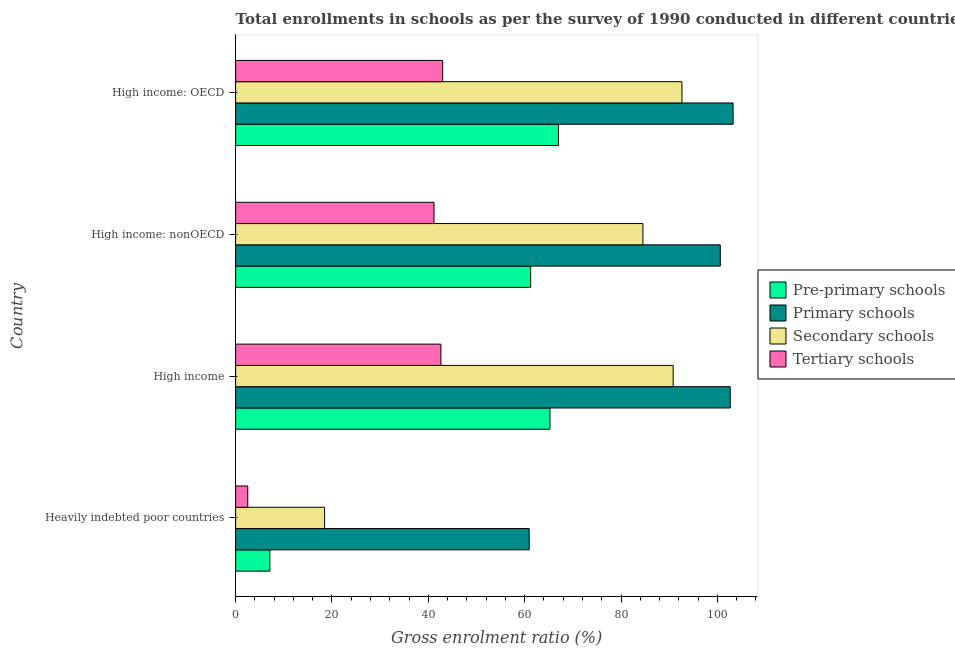How many different coloured bars are there?
Make the answer very short. 4. How many groups of bars are there?
Ensure brevity in your answer.  4. Are the number of bars per tick equal to the number of legend labels?
Offer a terse response. Yes. Are the number of bars on each tick of the Y-axis equal?
Your answer should be compact. Yes. What is the label of the 2nd group of bars from the top?
Ensure brevity in your answer.  High income: nonOECD. In how many cases, is the number of bars for a given country not equal to the number of legend labels?
Provide a succinct answer. 0. What is the gross enrolment ratio in pre-primary schools in High income: nonOECD?
Your answer should be very brief. 61.25. Across all countries, what is the maximum gross enrolment ratio in pre-primary schools?
Ensure brevity in your answer.  67.03. Across all countries, what is the minimum gross enrolment ratio in secondary schools?
Ensure brevity in your answer.  18.47. In which country was the gross enrolment ratio in secondary schools maximum?
Your response must be concise. High income: OECD. In which country was the gross enrolment ratio in primary schools minimum?
Offer a very short reply. Heavily indebted poor countries. What is the total gross enrolment ratio in pre-primary schools in the graph?
Your answer should be very brief. 200.64. What is the difference between the gross enrolment ratio in primary schools in High income: OECD and that in High income: nonOECD?
Give a very brief answer. 2.66. What is the difference between the gross enrolment ratio in primary schools in Heavily indebted poor countries and the gross enrolment ratio in pre-primary schools in High income: nonOECD?
Offer a terse response. -0.3. What is the average gross enrolment ratio in secondary schools per country?
Keep it short and to the point. 71.63. What is the difference between the gross enrolment ratio in pre-primary schools and gross enrolment ratio in secondary schools in High income?
Keep it short and to the point. -25.58. Is the gross enrolment ratio in tertiary schools in High income less than that in High income: nonOECD?
Provide a short and direct response. No. What is the difference between the highest and the second highest gross enrolment ratio in secondary schools?
Make the answer very short. 1.82. What is the difference between the highest and the lowest gross enrolment ratio in secondary schools?
Provide a short and direct response. 74.19. What does the 4th bar from the top in High income: OECD represents?
Your answer should be compact. Pre-primary schools. What does the 4th bar from the bottom in High income: OECD represents?
Your answer should be very brief. Tertiary schools. Is it the case that in every country, the sum of the gross enrolment ratio in pre-primary schools and gross enrolment ratio in primary schools is greater than the gross enrolment ratio in secondary schools?
Provide a short and direct response. Yes. Are all the bars in the graph horizontal?
Ensure brevity in your answer.  Yes. What is the difference between two consecutive major ticks on the X-axis?
Ensure brevity in your answer.  20. Does the graph contain any zero values?
Make the answer very short. No. How many legend labels are there?
Offer a terse response. 4. What is the title of the graph?
Offer a very short reply. Total enrollments in schools as per the survey of 1990 conducted in different countries. What is the label or title of the X-axis?
Ensure brevity in your answer.  Gross enrolment ratio (%). What is the label or title of the Y-axis?
Your answer should be very brief. Country. What is the Gross enrolment ratio (%) of Pre-primary schools in Heavily indebted poor countries?
Keep it short and to the point. 7.11. What is the Gross enrolment ratio (%) in Primary schools in Heavily indebted poor countries?
Your response must be concise. 60.95. What is the Gross enrolment ratio (%) of Secondary schools in Heavily indebted poor countries?
Your answer should be very brief. 18.47. What is the Gross enrolment ratio (%) of Tertiary schools in Heavily indebted poor countries?
Your response must be concise. 2.52. What is the Gross enrolment ratio (%) of Pre-primary schools in High income?
Ensure brevity in your answer.  65.26. What is the Gross enrolment ratio (%) of Primary schools in High income?
Your answer should be compact. 102.68. What is the Gross enrolment ratio (%) in Secondary schools in High income?
Provide a short and direct response. 90.83. What is the Gross enrolment ratio (%) of Tertiary schools in High income?
Offer a very short reply. 42.61. What is the Gross enrolment ratio (%) of Pre-primary schools in High income: nonOECD?
Provide a short and direct response. 61.25. What is the Gross enrolment ratio (%) in Primary schools in High income: nonOECD?
Your response must be concise. 100.61. What is the Gross enrolment ratio (%) in Secondary schools in High income: nonOECD?
Ensure brevity in your answer.  84.55. What is the Gross enrolment ratio (%) in Tertiary schools in High income: nonOECD?
Offer a very short reply. 41.18. What is the Gross enrolment ratio (%) in Pre-primary schools in High income: OECD?
Make the answer very short. 67.03. What is the Gross enrolment ratio (%) in Primary schools in High income: OECD?
Give a very brief answer. 103.27. What is the Gross enrolment ratio (%) in Secondary schools in High income: OECD?
Keep it short and to the point. 92.65. What is the Gross enrolment ratio (%) in Tertiary schools in High income: OECD?
Offer a very short reply. 42.98. Across all countries, what is the maximum Gross enrolment ratio (%) in Pre-primary schools?
Provide a succinct answer. 67.03. Across all countries, what is the maximum Gross enrolment ratio (%) in Primary schools?
Give a very brief answer. 103.27. Across all countries, what is the maximum Gross enrolment ratio (%) in Secondary schools?
Offer a terse response. 92.65. Across all countries, what is the maximum Gross enrolment ratio (%) in Tertiary schools?
Give a very brief answer. 42.98. Across all countries, what is the minimum Gross enrolment ratio (%) in Pre-primary schools?
Your answer should be very brief. 7.11. Across all countries, what is the minimum Gross enrolment ratio (%) in Primary schools?
Your answer should be very brief. 60.95. Across all countries, what is the minimum Gross enrolment ratio (%) of Secondary schools?
Provide a succinct answer. 18.47. Across all countries, what is the minimum Gross enrolment ratio (%) in Tertiary schools?
Offer a very short reply. 2.52. What is the total Gross enrolment ratio (%) in Pre-primary schools in the graph?
Your answer should be very brief. 200.64. What is the total Gross enrolment ratio (%) of Primary schools in the graph?
Your response must be concise. 367.5. What is the total Gross enrolment ratio (%) in Secondary schools in the graph?
Provide a short and direct response. 286.5. What is the total Gross enrolment ratio (%) in Tertiary schools in the graph?
Make the answer very short. 129.29. What is the difference between the Gross enrolment ratio (%) of Pre-primary schools in Heavily indebted poor countries and that in High income?
Provide a succinct answer. -58.15. What is the difference between the Gross enrolment ratio (%) in Primary schools in Heavily indebted poor countries and that in High income?
Provide a short and direct response. -41.73. What is the difference between the Gross enrolment ratio (%) of Secondary schools in Heavily indebted poor countries and that in High income?
Your answer should be compact. -72.36. What is the difference between the Gross enrolment ratio (%) of Tertiary schools in Heavily indebted poor countries and that in High income?
Give a very brief answer. -40.09. What is the difference between the Gross enrolment ratio (%) in Pre-primary schools in Heavily indebted poor countries and that in High income: nonOECD?
Make the answer very short. -54.14. What is the difference between the Gross enrolment ratio (%) of Primary schools in Heavily indebted poor countries and that in High income: nonOECD?
Your answer should be very brief. -39.66. What is the difference between the Gross enrolment ratio (%) of Secondary schools in Heavily indebted poor countries and that in High income: nonOECD?
Provide a succinct answer. -66.08. What is the difference between the Gross enrolment ratio (%) in Tertiary schools in Heavily indebted poor countries and that in High income: nonOECD?
Your answer should be compact. -38.66. What is the difference between the Gross enrolment ratio (%) in Pre-primary schools in Heavily indebted poor countries and that in High income: OECD?
Provide a succinct answer. -59.92. What is the difference between the Gross enrolment ratio (%) in Primary schools in Heavily indebted poor countries and that in High income: OECD?
Your response must be concise. -42.33. What is the difference between the Gross enrolment ratio (%) of Secondary schools in Heavily indebted poor countries and that in High income: OECD?
Make the answer very short. -74.19. What is the difference between the Gross enrolment ratio (%) in Tertiary schools in Heavily indebted poor countries and that in High income: OECD?
Offer a very short reply. -40.46. What is the difference between the Gross enrolment ratio (%) in Pre-primary schools in High income and that in High income: nonOECD?
Provide a succinct answer. 4.01. What is the difference between the Gross enrolment ratio (%) in Primary schools in High income and that in High income: nonOECD?
Provide a short and direct response. 2.07. What is the difference between the Gross enrolment ratio (%) in Secondary schools in High income and that in High income: nonOECD?
Give a very brief answer. 6.28. What is the difference between the Gross enrolment ratio (%) of Tertiary schools in High income and that in High income: nonOECD?
Ensure brevity in your answer.  1.43. What is the difference between the Gross enrolment ratio (%) in Pre-primary schools in High income and that in High income: OECD?
Your response must be concise. -1.77. What is the difference between the Gross enrolment ratio (%) of Primary schools in High income and that in High income: OECD?
Offer a very short reply. -0.59. What is the difference between the Gross enrolment ratio (%) of Secondary schools in High income and that in High income: OECD?
Offer a terse response. -1.82. What is the difference between the Gross enrolment ratio (%) of Tertiary schools in High income and that in High income: OECD?
Your answer should be very brief. -0.37. What is the difference between the Gross enrolment ratio (%) in Pre-primary schools in High income: nonOECD and that in High income: OECD?
Provide a short and direct response. -5.78. What is the difference between the Gross enrolment ratio (%) in Primary schools in High income: nonOECD and that in High income: OECD?
Provide a succinct answer. -2.66. What is the difference between the Gross enrolment ratio (%) of Secondary schools in High income: nonOECD and that in High income: OECD?
Keep it short and to the point. -8.11. What is the difference between the Gross enrolment ratio (%) in Tertiary schools in High income: nonOECD and that in High income: OECD?
Offer a very short reply. -1.79. What is the difference between the Gross enrolment ratio (%) of Pre-primary schools in Heavily indebted poor countries and the Gross enrolment ratio (%) of Primary schools in High income?
Offer a very short reply. -95.57. What is the difference between the Gross enrolment ratio (%) of Pre-primary schools in Heavily indebted poor countries and the Gross enrolment ratio (%) of Secondary schools in High income?
Your answer should be very brief. -83.72. What is the difference between the Gross enrolment ratio (%) of Pre-primary schools in Heavily indebted poor countries and the Gross enrolment ratio (%) of Tertiary schools in High income?
Give a very brief answer. -35.5. What is the difference between the Gross enrolment ratio (%) in Primary schools in Heavily indebted poor countries and the Gross enrolment ratio (%) in Secondary schools in High income?
Your response must be concise. -29.89. What is the difference between the Gross enrolment ratio (%) in Primary schools in Heavily indebted poor countries and the Gross enrolment ratio (%) in Tertiary schools in High income?
Your answer should be compact. 18.33. What is the difference between the Gross enrolment ratio (%) in Secondary schools in Heavily indebted poor countries and the Gross enrolment ratio (%) in Tertiary schools in High income?
Offer a terse response. -24.14. What is the difference between the Gross enrolment ratio (%) of Pre-primary schools in Heavily indebted poor countries and the Gross enrolment ratio (%) of Primary schools in High income: nonOECD?
Give a very brief answer. -93.5. What is the difference between the Gross enrolment ratio (%) in Pre-primary schools in Heavily indebted poor countries and the Gross enrolment ratio (%) in Secondary schools in High income: nonOECD?
Offer a very short reply. -77.44. What is the difference between the Gross enrolment ratio (%) in Pre-primary schools in Heavily indebted poor countries and the Gross enrolment ratio (%) in Tertiary schools in High income: nonOECD?
Provide a short and direct response. -34.07. What is the difference between the Gross enrolment ratio (%) of Primary schools in Heavily indebted poor countries and the Gross enrolment ratio (%) of Secondary schools in High income: nonOECD?
Offer a terse response. -23.6. What is the difference between the Gross enrolment ratio (%) of Primary schools in Heavily indebted poor countries and the Gross enrolment ratio (%) of Tertiary schools in High income: nonOECD?
Offer a terse response. 19.76. What is the difference between the Gross enrolment ratio (%) in Secondary schools in Heavily indebted poor countries and the Gross enrolment ratio (%) in Tertiary schools in High income: nonOECD?
Your answer should be compact. -22.71. What is the difference between the Gross enrolment ratio (%) of Pre-primary schools in Heavily indebted poor countries and the Gross enrolment ratio (%) of Primary schools in High income: OECD?
Offer a terse response. -96.16. What is the difference between the Gross enrolment ratio (%) of Pre-primary schools in Heavily indebted poor countries and the Gross enrolment ratio (%) of Secondary schools in High income: OECD?
Offer a terse response. -85.54. What is the difference between the Gross enrolment ratio (%) of Pre-primary schools in Heavily indebted poor countries and the Gross enrolment ratio (%) of Tertiary schools in High income: OECD?
Keep it short and to the point. -35.87. What is the difference between the Gross enrolment ratio (%) of Primary schools in Heavily indebted poor countries and the Gross enrolment ratio (%) of Secondary schools in High income: OECD?
Your response must be concise. -31.71. What is the difference between the Gross enrolment ratio (%) in Primary schools in Heavily indebted poor countries and the Gross enrolment ratio (%) in Tertiary schools in High income: OECD?
Ensure brevity in your answer.  17.97. What is the difference between the Gross enrolment ratio (%) in Secondary schools in Heavily indebted poor countries and the Gross enrolment ratio (%) in Tertiary schools in High income: OECD?
Make the answer very short. -24.51. What is the difference between the Gross enrolment ratio (%) in Pre-primary schools in High income and the Gross enrolment ratio (%) in Primary schools in High income: nonOECD?
Ensure brevity in your answer.  -35.35. What is the difference between the Gross enrolment ratio (%) of Pre-primary schools in High income and the Gross enrolment ratio (%) of Secondary schools in High income: nonOECD?
Offer a terse response. -19.29. What is the difference between the Gross enrolment ratio (%) in Pre-primary schools in High income and the Gross enrolment ratio (%) in Tertiary schools in High income: nonOECD?
Ensure brevity in your answer.  24.07. What is the difference between the Gross enrolment ratio (%) in Primary schools in High income and the Gross enrolment ratio (%) in Secondary schools in High income: nonOECD?
Keep it short and to the point. 18.13. What is the difference between the Gross enrolment ratio (%) in Primary schools in High income and the Gross enrolment ratio (%) in Tertiary schools in High income: nonOECD?
Your answer should be very brief. 61.49. What is the difference between the Gross enrolment ratio (%) of Secondary schools in High income and the Gross enrolment ratio (%) of Tertiary schools in High income: nonOECD?
Provide a succinct answer. 49.65. What is the difference between the Gross enrolment ratio (%) in Pre-primary schools in High income and the Gross enrolment ratio (%) in Primary schools in High income: OECD?
Ensure brevity in your answer.  -38.02. What is the difference between the Gross enrolment ratio (%) of Pre-primary schools in High income and the Gross enrolment ratio (%) of Secondary schools in High income: OECD?
Give a very brief answer. -27.4. What is the difference between the Gross enrolment ratio (%) in Pre-primary schools in High income and the Gross enrolment ratio (%) in Tertiary schools in High income: OECD?
Offer a very short reply. 22.28. What is the difference between the Gross enrolment ratio (%) in Primary schools in High income and the Gross enrolment ratio (%) in Secondary schools in High income: OECD?
Provide a succinct answer. 10.02. What is the difference between the Gross enrolment ratio (%) of Primary schools in High income and the Gross enrolment ratio (%) of Tertiary schools in High income: OECD?
Make the answer very short. 59.7. What is the difference between the Gross enrolment ratio (%) of Secondary schools in High income and the Gross enrolment ratio (%) of Tertiary schools in High income: OECD?
Your answer should be very brief. 47.85. What is the difference between the Gross enrolment ratio (%) in Pre-primary schools in High income: nonOECD and the Gross enrolment ratio (%) in Primary schools in High income: OECD?
Your answer should be compact. -42.03. What is the difference between the Gross enrolment ratio (%) of Pre-primary schools in High income: nonOECD and the Gross enrolment ratio (%) of Secondary schools in High income: OECD?
Give a very brief answer. -31.41. What is the difference between the Gross enrolment ratio (%) of Pre-primary schools in High income: nonOECD and the Gross enrolment ratio (%) of Tertiary schools in High income: OECD?
Offer a very short reply. 18.27. What is the difference between the Gross enrolment ratio (%) of Primary schools in High income: nonOECD and the Gross enrolment ratio (%) of Secondary schools in High income: OECD?
Make the answer very short. 7.96. What is the difference between the Gross enrolment ratio (%) of Primary schools in High income: nonOECD and the Gross enrolment ratio (%) of Tertiary schools in High income: OECD?
Your response must be concise. 57.63. What is the difference between the Gross enrolment ratio (%) in Secondary schools in High income: nonOECD and the Gross enrolment ratio (%) in Tertiary schools in High income: OECD?
Your answer should be very brief. 41.57. What is the average Gross enrolment ratio (%) in Pre-primary schools per country?
Provide a short and direct response. 50.16. What is the average Gross enrolment ratio (%) of Primary schools per country?
Your response must be concise. 91.88. What is the average Gross enrolment ratio (%) of Secondary schools per country?
Provide a succinct answer. 71.63. What is the average Gross enrolment ratio (%) in Tertiary schools per country?
Make the answer very short. 32.32. What is the difference between the Gross enrolment ratio (%) in Pre-primary schools and Gross enrolment ratio (%) in Primary schools in Heavily indebted poor countries?
Keep it short and to the point. -53.84. What is the difference between the Gross enrolment ratio (%) in Pre-primary schools and Gross enrolment ratio (%) in Secondary schools in Heavily indebted poor countries?
Provide a short and direct response. -11.36. What is the difference between the Gross enrolment ratio (%) in Pre-primary schools and Gross enrolment ratio (%) in Tertiary schools in Heavily indebted poor countries?
Give a very brief answer. 4.59. What is the difference between the Gross enrolment ratio (%) of Primary schools and Gross enrolment ratio (%) of Secondary schools in Heavily indebted poor countries?
Your response must be concise. 42.48. What is the difference between the Gross enrolment ratio (%) of Primary schools and Gross enrolment ratio (%) of Tertiary schools in Heavily indebted poor countries?
Offer a terse response. 58.42. What is the difference between the Gross enrolment ratio (%) of Secondary schools and Gross enrolment ratio (%) of Tertiary schools in Heavily indebted poor countries?
Give a very brief answer. 15.95. What is the difference between the Gross enrolment ratio (%) of Pre-primary schools and Gross enrolment ratio (%) of Primary schools in High income?
Provide a short and direct response. -37.42. What is the difference between the Gross enrolment ratio (%) of Pre-primary schools and Gross enrolment ratio (%) of Secondary schools in High income?
Give a very brief answer. -25.58. What is the difference between the Gross enrolment ratio (%) in Pre-primary schools and Gross enrolment ratio (%) in Tertiary schools in High income?
Offer a terse response. 22.64. What is the difference between the Gross enrolment ratio (%) of Primary schools and Gross enrolment ratio (%) of Secondary schools in High income?
Provide a succinct answer. 11.85. What is the difference between the Gross enrolment ratio (%) of Primary schools and Gross enrolment ratio (%) of Tertiary schools in High income?
Provide a short and direct response. 60.06. What is the difference between the Gross enrolment ratio (%) in Secondary schools and Gross enrolment ratio (%) in Tertiary schools in High income?
Offer a very short reply. 48.22. What is the difference between the Gross enrolment ratio (%) of Pre-primary schools and Gross enrolment ratio (%) of Primary schools in High income: nonOECD?
Your answer should be compact. -39.36. What is the difference between the Gross enrolment ratio (%) of Pre-primary schools and Gross enrolment ratio (%) of Secondary schools in High income: nonOECD?
Give a very brief answer. -23.3. What is the difference between the Gross enrolment ratio (%) in Pre-primary schools and Gross enrolment ratio (%) in Tertiary schools in High income: nonOECD?
Your response must be concise. 20.06. What is the difference between the Gross enrolment ratio (%) in Primary schools and Gross enrolment ratio (%) in Secondary schools in High income: nonOECD?
Your response must be concise. 16.06. What is the difference between the Gross enrolment ratio (%) in Primary schools and Gross enrolment ratio (%) in Tertiary schools in High income: nonOECD?
Provide a short and direct response. 59.43. What is the difference between the Gross enrolment ratio (%) of Secondary schools and Gross enrolment ratio (%) of Tertiary schools in High income: nonOECD?
Make the answer very short. 43.36. What is the difference between the Gross enrolment ratio (%) of Pre-primary schools and Gross enrolment ratio (%) of Primary schools in High income: OECD?
Your response must be concise. -36.24. What is the difference between the Gross enrolment ratio (%) of Pre-primary schools and Gross enrolment ratio (%) of Secondary schools in High income: OECD?
Offer a very short reply. -25.63. What is the difference between the Gross enrolment ratio (%) in Pre-primary schools and Gross enrolment ratio (%) in Tertiary schools in High income: OECD?
Your answer should be very brief. 24.05. What is the difference between the Gross enrolment ratio (%) of Primary schools and Gross enrolment ratio (%) of Secondary schools in High income: OECD?
Give a very brief answer. 10.62. What is the difference between the Gross enrolment ratio (%) of Primary schools and Gross enrolment ratio (%) of Tertiary schools in High income: OECD?
Give a very brief answer. 60.29. What is the difference between the Gross enrolment ratio (%) of Secondary schools and Gross enrolment ratio (%) of Tertiary schools in High income: OECD?
Your response must be concise. 49.68. What is the ratio of the Gross enrolment ratio (%) in Pre-primary schools in Heavily indebted poor countries to that in High income?
Your answer should be compact. 0.11. What is the ratio of the Gross enrolment ratio (%) of Primary schools in Heavily indebted poor countries to that in High income?
Provide a short and direct response. 0.59. What is the ratio of the Gross enrolment ratio (%) in Secondary schools in Heavily indebted poor countries to that in High income?
Offer a terse response. 0.2. What is the ratio of the Gross enrolment ratio (%) of Tertiary schools in Heavily indebted poor countries to that in High income?
Your answer should be very brief. 0.06. What is the ratio of the Gross enrolment ratio (%) of Pre-primary schools in Heavily indebted poor countries to that in High income: nonOECD?
Make the answer very short. 0.12. What is the ratio of the Gross enrolment ratio (%) in Primary schools in Heavily indebted poor countries to that in High income: nonOECD?
Your answer should be very brief. 0.61. What is the ratio of the Gross enrolment ratio (%) in Secondary schools in Heavily indebted poor countries to that in High income: nonOECD?
Provide a short and direct response. 0.22. What is the ratio of the Gross enrolment ratio (%) of Tertiary schools in Heavily indebted poor countries to that in High income: nonOECD?
Provide a succinct answer. 0.06. What is the ratio of the Gross enrolment ratio (%) in Pre-primary schools in Heavily indebted poor countries to that in High income: OECD?
Your answer should be compact. 0.11. What is the ratio of the Gross enrolment ratio (%) in Primary schools in Heavily indebted poor countries to that in High income: OECD?
Your answer should be compact. 0.59. What is the ratio of the Gross enrolment ratio (%) in Secondary schools in Heavily indebted poor countries to that in High income: OECD?
Offer a very short reply. 0.2. What is the ratio of the Gross enrolment ratio (%) of Tertiary schools in Heavily indebted poor countries to that in High income: OECD?
Your response must be concise. 0.06. What is the ratio of the Gross enrolment ratio (%) of Pre-primary schools in High income to that in High income: nonOECD?
Your response must be concise. 1.07. What is the ratio of the Gross enrolment ratio (%) of Primary schools in High income to that in High income: nonOECD?
Keep it short and to the point. 1.02. What is the ratio of the Gross enrolment ratio (%) of Secondary schools in High income to that in High income: nonOECD?
Make the answer very short. 1.07. What is the ratio of the Gross enrolment ratio (%) of Tertiary schools in High income to that in High income: nonOECD?
Your answer should be compact. 1.03. What is the ratio of the Gross enrolment ratio (%) of Pre-primary schools in High income to that in High income: OECD?
Your answer should be very brief. 0.97. What is the ratio of the Gross enrolment ratio (%) of Secondary schools in High income to that in High income: OECD?
Offer a terse response. 0.98. What is the ratio of the Gross enrolment ratio (%) in Tertiary schools in High income to that in High income: OECD?
Your response must be concise. 0.99. What is the ratio of the Gross enrolment ratio (%) of Pre-primary schools in High income: nonOECD to that in High income: OECD?
Provide a short and direct response. 0.91. What is the ratio of the Gross enrolment ratio (%) of Primary schools in High income: nonOECD to that in High income: OECD?
Keep it short and to the point. 0.97. What is the ratio of the Gross enrolment ratio (%) in Secondary schools in High income: nonOECD to that in High income: OECD?
Make the answer very short. 0.91. What is the ratio of the Gross enrolment ratio (%) of Tertiary schools in High income: nonOECD to that in High income: OECD?
Give a very brief answer. 0.96. What is the difference between the highest and the second highest Gross enrolment ratio (%) in Pre-primary schools?
Your answer should be compact. 1.77. What is the difference between the highest and the second highest Gross enrolment ratio (%) of Primary schools?
Make the answer very short. 0.59. What is the difference between the highest and the second highest Gross enrolment ratio (%) in Secondary schools?
Provide a short and direct response. 1.82. What is the difference between the highest and the second highest Gross enrolment ratio (%) in Tertiary schools?
Make the answer very short. 0.37. What is the difference between the highest and the lowest Gross enrolment ratio (%) of Pre-primary schools?
Keep it short and to the point. 59.92. What is the difference between the highest and the lowest Gross enrolment ratio (%) of Primary schools?
Make the answer very short. 42.33. What is the difference between the highest and the lowest Gross enrolment ratio (%) of Secondary schools?
Provide a short and direct response. 74.19. What is the difference between the highest and the lowest Gross enrolment ratio (%) in Tertiary schools?
Offer a terse response. 40.46. 